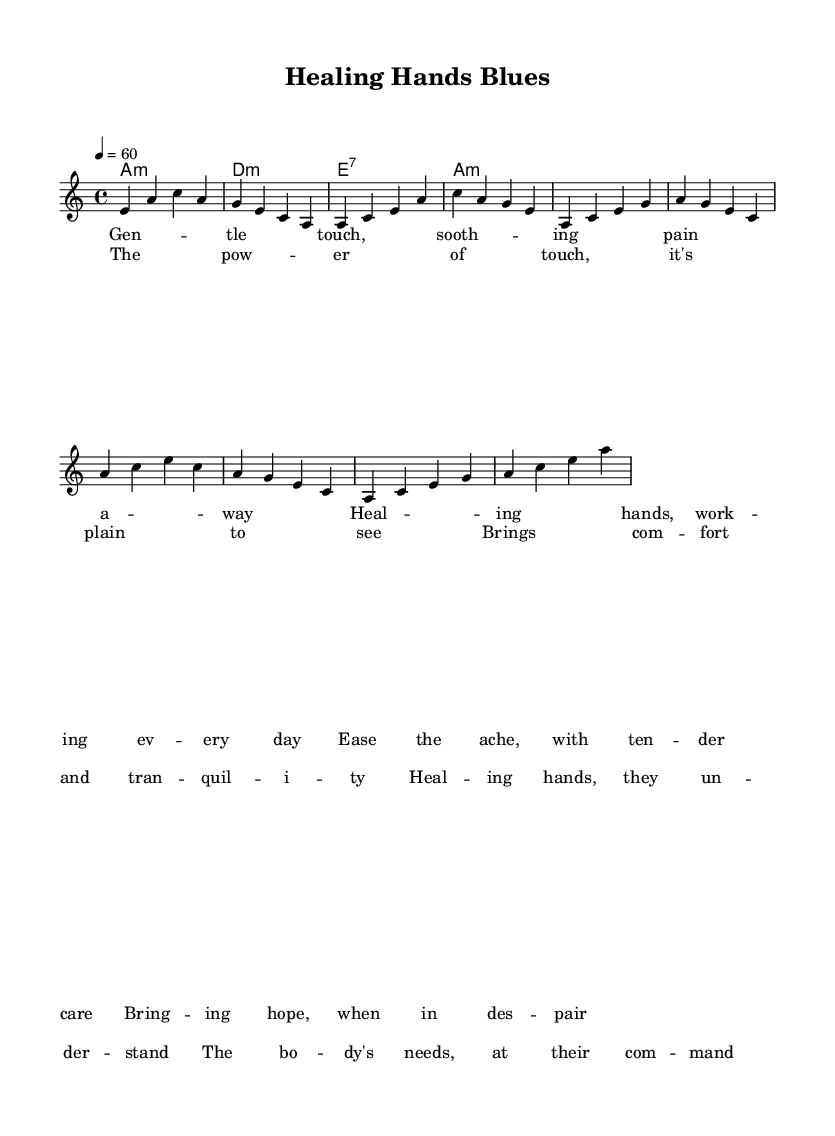What is the key signature of this music? The key signature is A minor, which has no sharps or flats.
Answer: A minor What is the time signature of this music? The time signature is indicated as four beats per measure, which is shown as 4/4.
Answer: 4/4 What is the tempo marking for this piece? The tempo is set at 60 beats per minute, indicated by the numerical marking at the beginning of the piece.
Answer: 60 Which chord is used at the beginning of the harmonies? The first chord in the harmonic progression is identified as A minor, which is specified in the chord mode.
Answer: A minor How many lines of lyrics are provided for the verse? There are four lines of lyrics written for the verse, as seen in the lyric mode section corresponding to the verse.
Answer: 4 What is the prominent theme explored in the lyrics of this blues ballad? The lyrics focus on the healing and comforting effects of gentle human touch, emphasized throughout the verses and chorus.
Answer: Healing power of touch What type of blues song is this composition? This composition is a slow, soulful blues ballad that explores themes of healing and emotional support through touch.
Answer: Slow, soulful blues ballad 